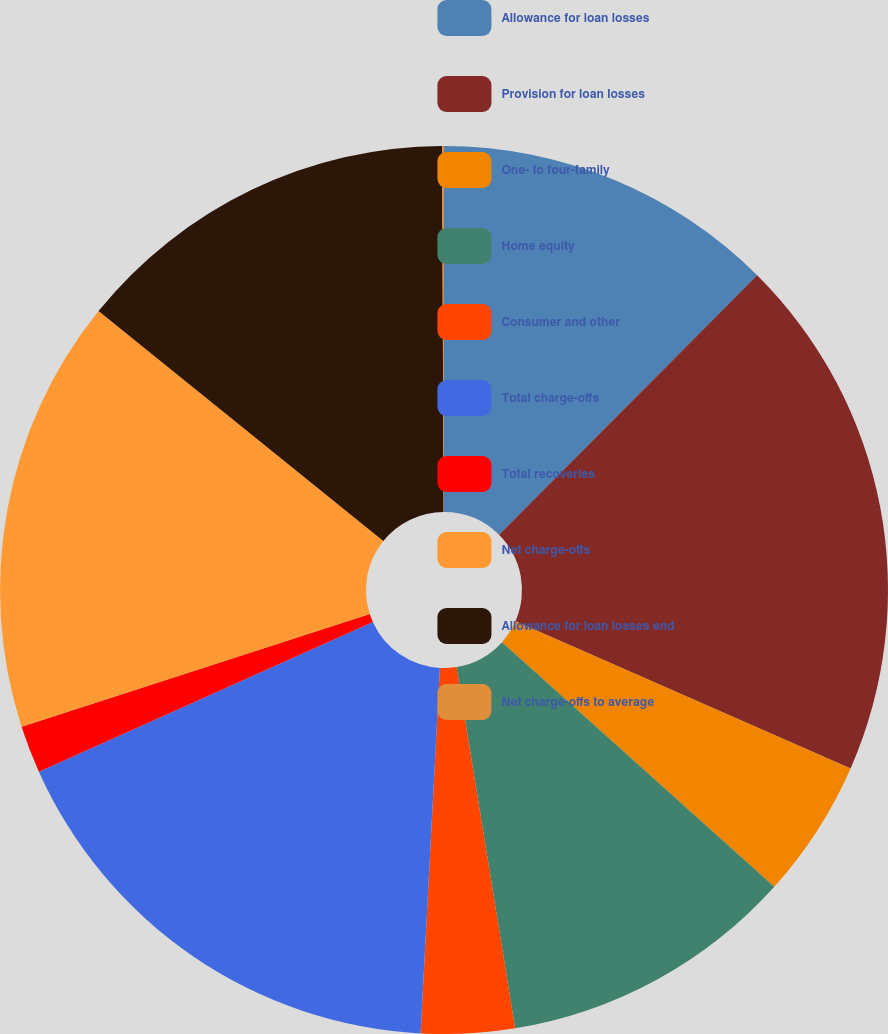Convert chart. <chart><loc_0><loc_0><loc_500><loc_500><pie_chart><fcel>Allowance for loan losses<fcel>Provision for loan losses<fcel>One- to four-family<fcel>Home equity<fcel>Consumer and other<fcel>Total charge-offs<fcel>Total recoveries<fcel>Net charge-offs<fcel>Allowance for loan losses end<fcel>Net charge-offs to average<nl><fcel>12.46%<fcel>19.12%<fcel>5.07%<fcel>10.79%<fcel>3.4%<fcel>17.45%<fcel>1.73%<fcel>15.79%<fcel>14.12%<fcel>0.07%<nl></chart> 